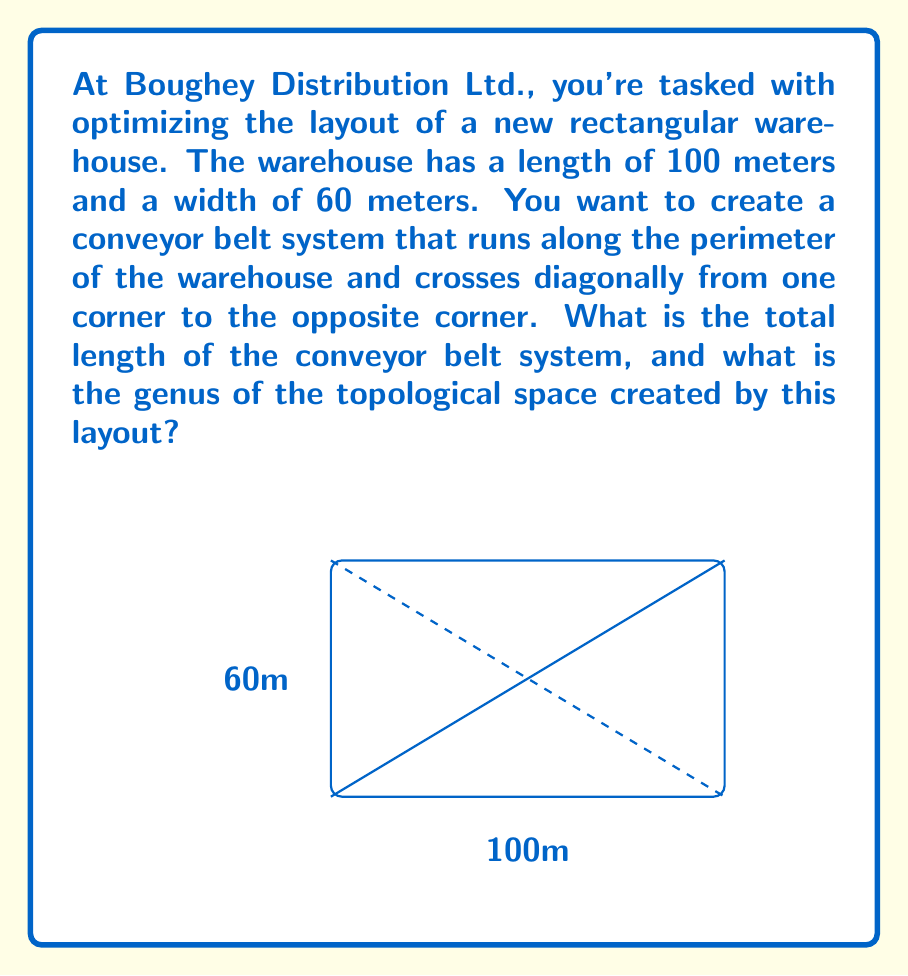Solve this math problem. To solve this problem, we need to break it down into two parts: calculating the length of the conveyor belt and determining the genus of the topological space.

1. Calculating the conveyor belt length:
   a) Perimeter of the warehouse:
      $$2 \times (100\text{ m} + 60\text{ m}) = 320\text{ m}$$
   b) Length of the diagonal:
      Using the Pythagorean theorem: $\sqrt{100^2 + 60^2} = \sqrt{13600} = 116.62\text{ m}$
   c) Total length of the conveyor belt:
      $$320\text{ m} + 116.62\text{ m} = 436.62\text{ m}$$

2. Determining the genus of the topological space:
   The conveyor belt system divides the warehouse floor into two regions. In topological terms, this creates a simple closed curve on a plane. The resulting space is homeomorphic to a sphere with one handle (or a torus).

   The genus of a topological space is the number of handles or "holes" it has. In this case:
   - The warehouse floor is initially a topological disk (genus 0)
   - The conveyor belt system adds one handle to this disk
   - Therefore, the genus of the resulting topological space is 1

The genus can also be calculated using the Euler characteristic χ:
   $$χ = V - E + F = 2 - 2g$$
   where V is the number of vertices, E is the number of edges, and F is the number of faces.

   In our case:
   V = 4 (four corners of the warehouse)
   E = 5 (four sides plus one diagonal)
   F = 2 (two regions created by the diagonal)

   $$4 - 5 + 2 = 1 = 2 - 2g$$
   $$2g = 1$$
   $$g = \frac{1}{2}$$

   Since the genus must be a non-negative integer, we round up to 1.
Answer: The total length of the conveyor belt system is 436.62 meters, and the genus of the topological space created by this layout is 1. 